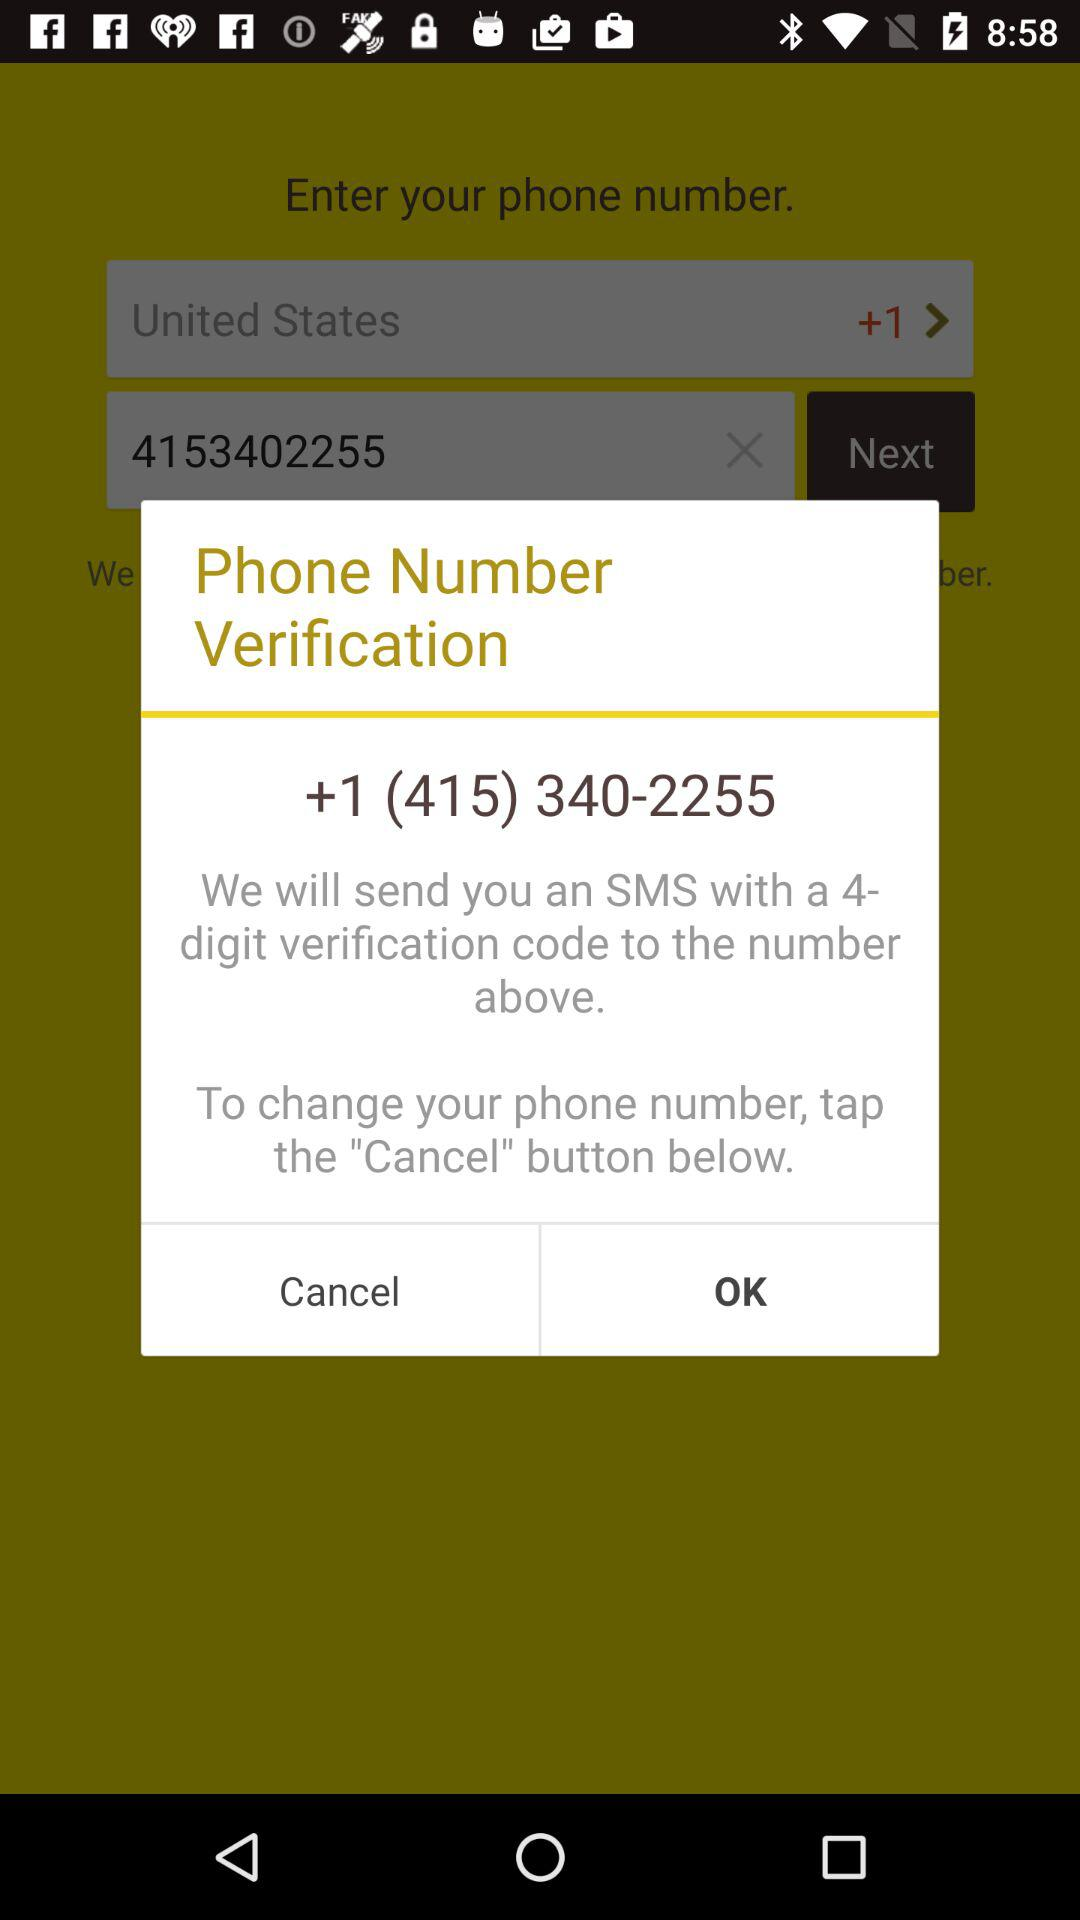What is the phone number for verification? The phone number is +1 (415) 340-2255. 